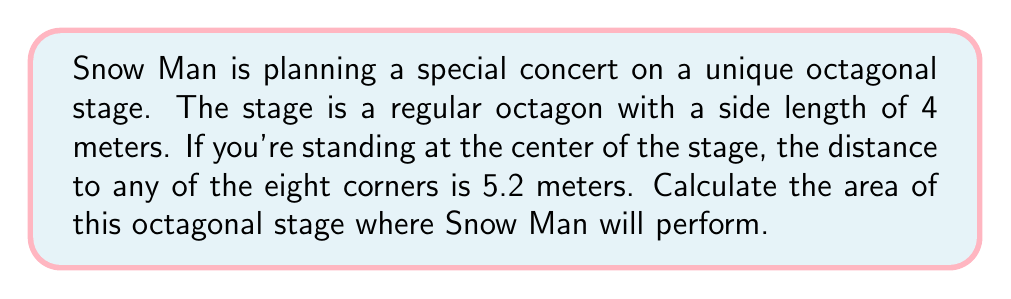Show me your answer to this math problem. Let's approach this step-by-step:

1) In a regular octagon, we can divide it into 8 congruent triangles from the center.

2) Each of these triangles has:
   - A base of 4 meters (the side of the octagon)
   - A height of 5.2 meters (given as the distance from center to corner)

3) The area of one triangle is:
   $$A_{triangle} = \frac{1}{2} \times base \times height = \frac{1}{2} \times 4 \times 5.2 = 10.4 \text{ m}^2$$

4) Since there are 8 such triangles, the total area is:
   $$A_{octagon} = 8 \times A_{triangle} = 8 \times 10.4 = 83.2 \text{ m}^2$$

5) We can verify this using the formula for the area of a regular octagon:
   $$A = 2a^2(1+\sqrt{2})$$
   where $a$ is the side length.

6) Plugging in $a = 4$:
   $$A = 2(4^2)(1+\sqrt{2}) = 32(1+\sqrt{2}) \approx 83.2 \text{ m}^2$$

This confirms our calculation.

[asy]
import geometry;

size(200);

pair A = (0,0);
pair B = (4,0);
pair C = (4+2*sqrt(2),2*sqrt(2));
pair D = (4+2*sqrt(2),4+2*sqrt(2));
pair E = (4,4+4*sqrt(2));
pair F = (0,4+4*sqrt(2));
pair G = (-2*sqrt(2),4+2*sqrt(2));
pair H = (-2*sqrt(2),2*sqrt(2));
pair O = (2,2+2*sqrt(2));

draw(A--B--C--D--E--F--G--H--cycle);
draw(O--A);
draw(O--B);
draw(O--C);
draw(O--D);
draw(O--E);
draw(O--F);
draw(O--G);
draw(O--H);

label("4m", (A+B)/2, S);
label("5.2m", (O+B)/2, SE);

dot(O);
[/asy]
Answer: The area of the octagonal stage is 83.2 square meters. 